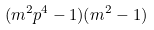Convert formula to latex. <formula><loc_0><loc_0><loc_500><loc_500>( m ^ { 2 } p ^ { 4 } - 1 ) ( m ^ { 2 } - 1 )</formula> 